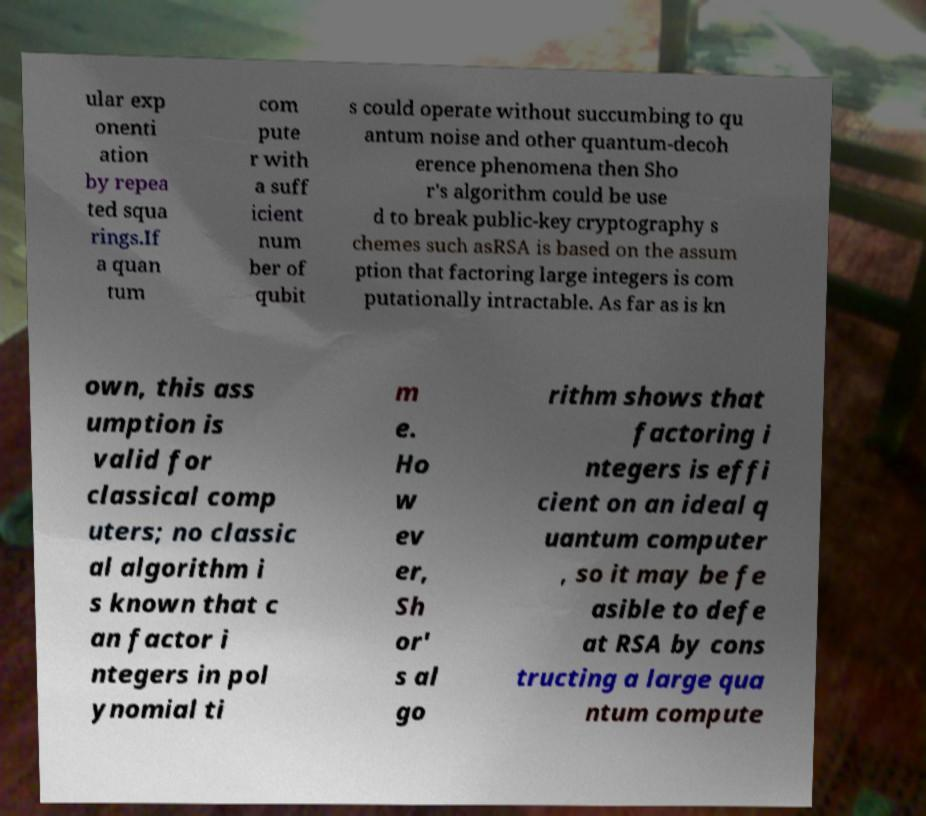Please read and relay the text visible in this image. What does it say? ular exp onenti ation by repea ted squa rings.If a quan tum com pute r with a suff icient num ber of qubit s could operate without succumbing to qu antum noise and other quantum-decoh erence phenomena then Sho r's algorithm could be use d to break public-key cryptography s chemes such asRSA is based on the assum ption that factoring large integers is com putationally intractable. As far as is kn own, this ass umption is valid for classical comp uters; no classic al algorithm i s known that c an factor i ntegers in pol ynomial ti m e. Ho w ev er, Sh or' s al go rithm shows that factoring i ntegers is effi cient on an ideal q uantum computer , so it may be fe asible to defe at RSA by cons tructing a large qua ntum compute 